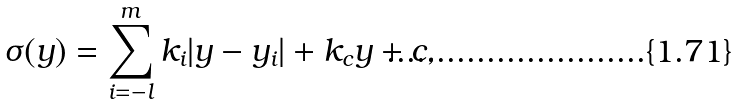<formula> <loc_0><loc_0><loc_500><loc_500>\sigma ( y ) = \sum _ { i = - l } ^ { m } k _ { i } | y - y _ { i } | + k _ { c } y + c , \,</formula> 